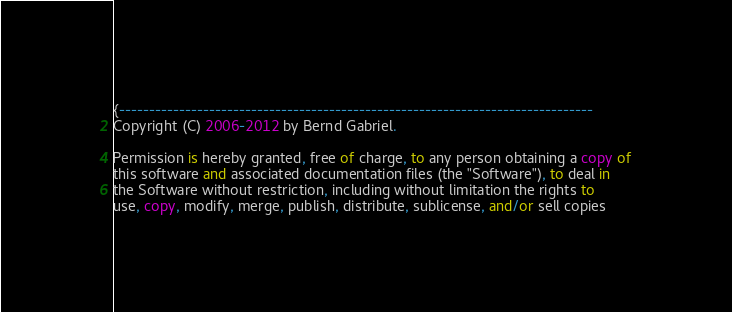<code> <loc_0><loc_0><loc_500><loc_500><_Pascal_>{-------------------------------------------------------------------------------
Copyright (C) 2006-2012 by Bernd Gabriel.

Permission is hereby granted, free of charge, to any person obtaining a copy of
this software and associated documentation files (the "Software"), to deal in
the Software without restriction, including without limitation the rights to
use, copy, modify, merge, publish, distribute, sublicense, and/or sell copies</code> 